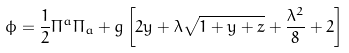<formula> <loc_0><loc_0><loc_500><loc_500>\phi = \frac { 1 } { 2 } \Pi ^ { a } \Pi _ { a } + g \left [ 2 y + \lambda \sqrt { 1 + y + z } + \frac { \lambda ^ { 2 } } { 8 } + 2 \right ]</formula> 